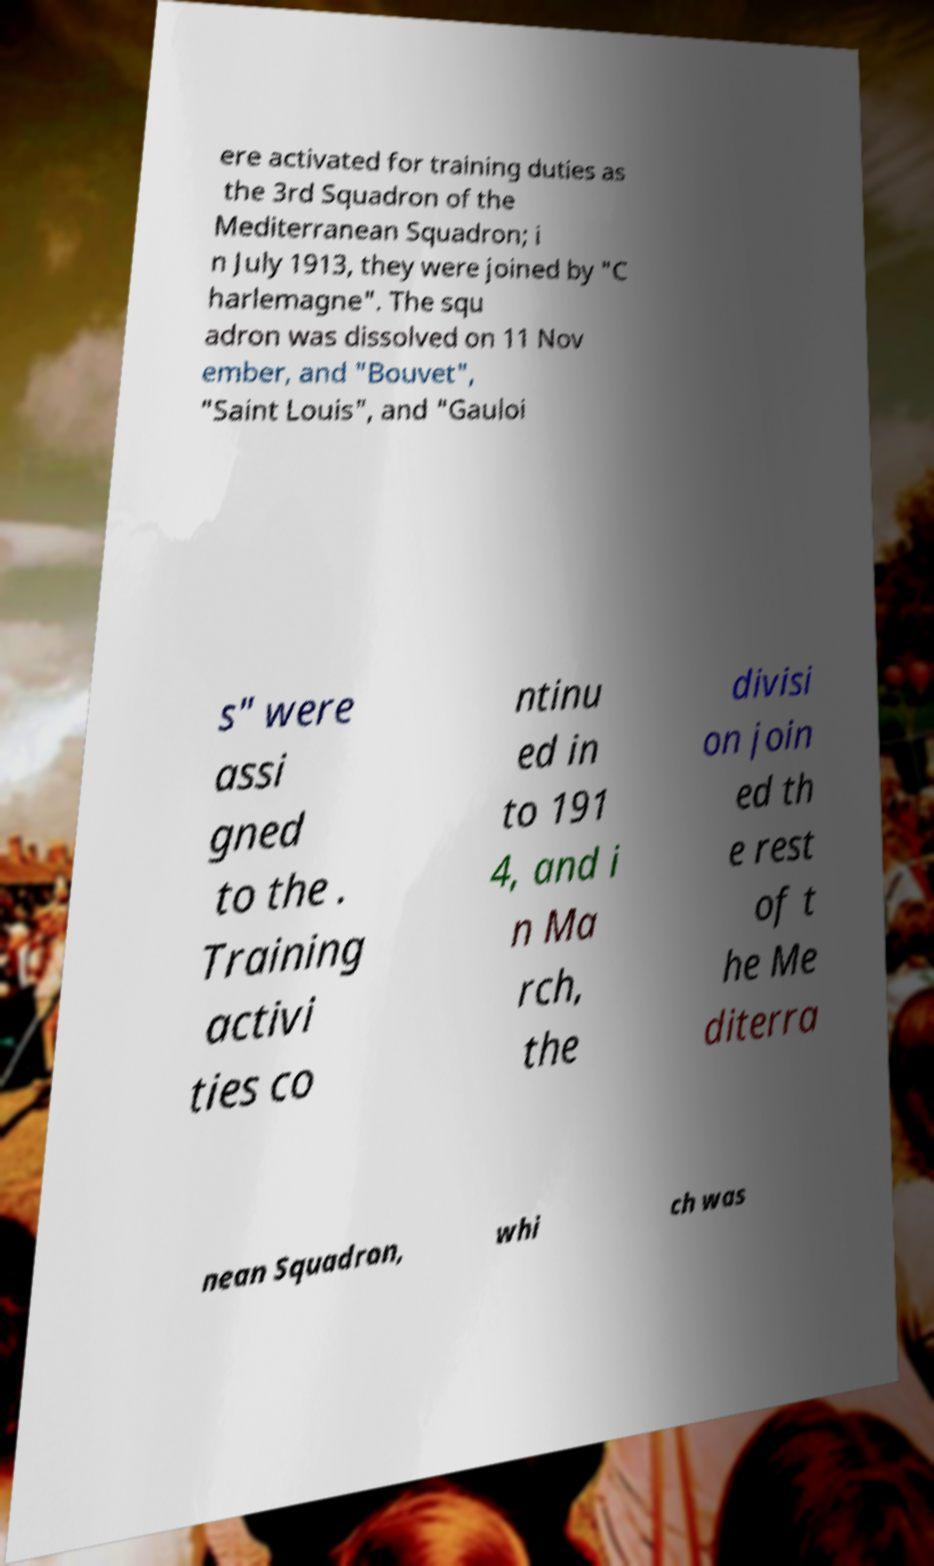Please identify and transcribe the text found in this image. ere activated for training duties as the 3rd Squadron of the Mediterranean Squadron; i n July 1913, they were joined by "C harlemagne". The squ adron was dissolved on 11 Nov ember, and "Bouvet", "Saint Louis", and "Gauloi s" were assi gned to the . Training activi ties co ntinu ed in to 191 4, and i n Ma rch, the divisi on join ed th e rest of t he Me diterra nean Squadron, whi ch was 